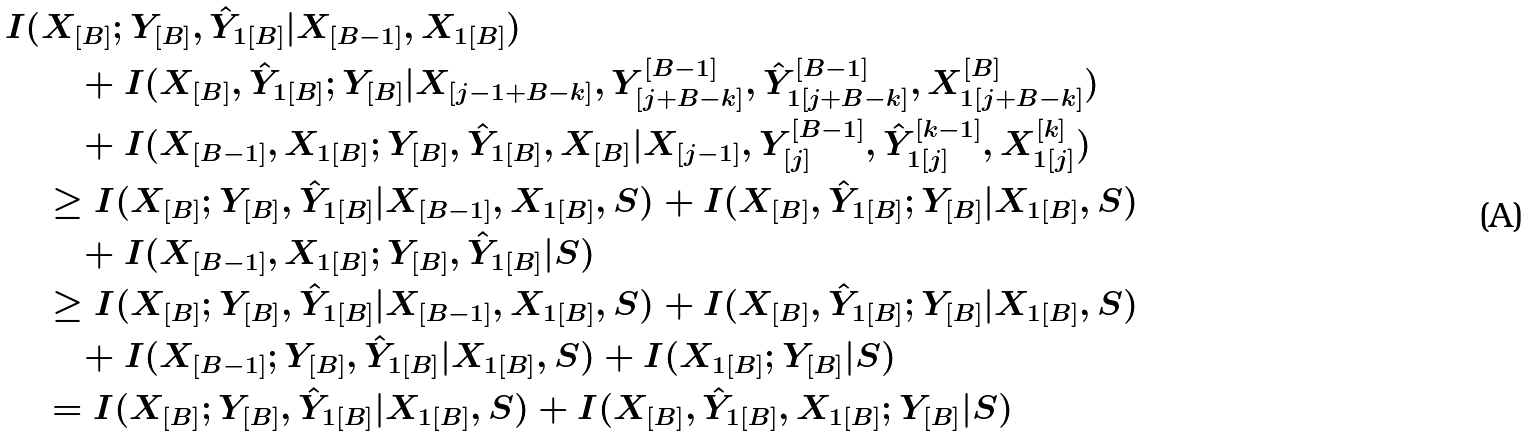Convert formula to latex. <formula><loc_0><loc_0><loc_500><loc_500>I ( & X _ { [ B ] } ; Y _ { [ B ] } , \hat { Y } _ { 1 [ B ] } | X _ { [ B - 1 ] } , X _ { 1 [ B ] } ) \\ & \quad + I ( X _ { [ B ] } , \hat { Y } _ { 1 [ B ] } ; Y _ { [ B ] } | X _ { [ j - 1 + B - k ] } , Y _ { [ j + B - k ] } ^ { [ B - 1 ] } , \hat { Y } _ { 1 [ j + B - k ] } ^ { [ B - 1 ] } , X _ { 1 [ j + B - k ] } ^ { [ B ] } ) \\ & \quad + I ( X _ { [ B - 1 ] } , X _ { 1 [ B ] } ; Y _ { [ B ] } , \hat { Y } _ { 1 [ B ] } , X _ { [ B ] } | X _ { [ j - 1 ] } , Y _ { [ j ] } ^ { [ B - 1 ] } , \hat { Y } _ { 1 [ j ] } ^ { [ k - 1 ] } , X _ { 1 [ j ] } ^ { [ k ] } ) \\ & \geq I ( X _ { [ B ] } ; Y _ { [ B ] } , \hat { Y } _ { 1 [ B ] } | X _ { [ B - 1 ] } , X _ { 1 [ B ] } , S ) + I ( X _ { [ B ] } , \hat { Y } _ { 1 [ B ] } ; Y _ { [ B ] } | X _ { 1 [ B ] } , S ) \\ & \quad + I ( X _ { [ B - 1 ] } , X _ { 1 [ B ] } ; Y _ { [ B ] } , \hat { Y } _ { 1 [ B ] } | S ) \\ & \geq I ( X _ { [ B ] } ; Y _ { [ B ] } , \hat { Y } _ { 1 [ B ] } | X _ { [ B - 1 ] } , X _ { 1 [ B ] } , S ) + I ( X _ { [ B ] } , \hat { Y } _ { 1 [ B ] } ; Y _ { [ B ] } | X _ { 1 [ B ] } , S ) \\ & \quad + I ( X _ { [ B - 1 ] } ; Y _ { [ B ] } , \hat { Y } _ { 1 [ B ] } | X _ { 1 [ B ] } , S ) + I ( X _ { 1 [ B ] } ; Y _ { [ B ] } | S ) \\ & = I ( X _ { [ B ] } ; Y _ { [ B ] } , \hat { Y } _ { 1 [ B ] } | X _ { 1 [ B ] } , S ) + I ( X _ { [ B ] } , \hat { Y } _ { 1 [ B ] } , X _ { 1 [ B ] } ; Y _ { [ B ] } | S )</formula> 